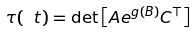Convert formula to latex. <formula><loc_0><loc_0><loc_500><loc_500>\tau ( \ t ) = \det \left [ A e ^ { g ( B ) } C ^ { \top } \right ]</formula> 